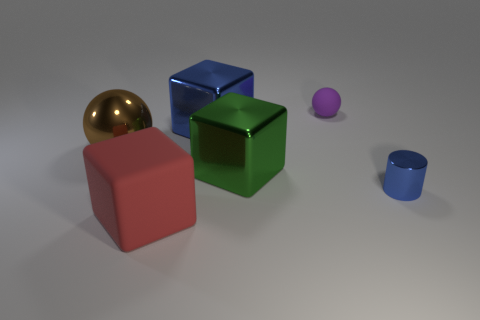Is there anything else that has the same shape as the tiny blue object?
Keep it short and to the point. No. Does the large cube that is behind the brown object have the same material as the large brown ball?
Offer a terse response. Yes. How many cylinders are either tiny blue objects or large green metal things?
Keep it short and to the point. 1. What shape is the large thing that is left of the big blue shiny object and right of the large shiny sphere?
Your answer should be very brief. Cube. The matte object on the left side of the matte object behind the rubber object to the left of the blue metal cube is what color?
Your response must be concise. Red. Is the number of small purple objects on the right side of the tiny purple rubber thing less than the number of big brown metallic balls?
Provide a short and direct response. Yes. Does the metal thing that is on the right side of the purple rubber ball have the same shape as the blue object that is on the left side of the small sphere?
Ensure brevity in your answer.  No. How many objects are objects that are on the left side of the large red rubber object or big purple metallic spheres?
Your answer should be compact. 1. There is a cube that is the same color as the tiny metal cylinder; what material is it?
Your answer should be compact. Metal. Is there a thing right of the rubber thing that is behind the matte thing in front of the purple thing?
Offer a very short reply. Yes. 